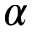Convert formula to latex. <formula><loc_0><loc_0><loc_500><loc_500>\alpha</formula> 